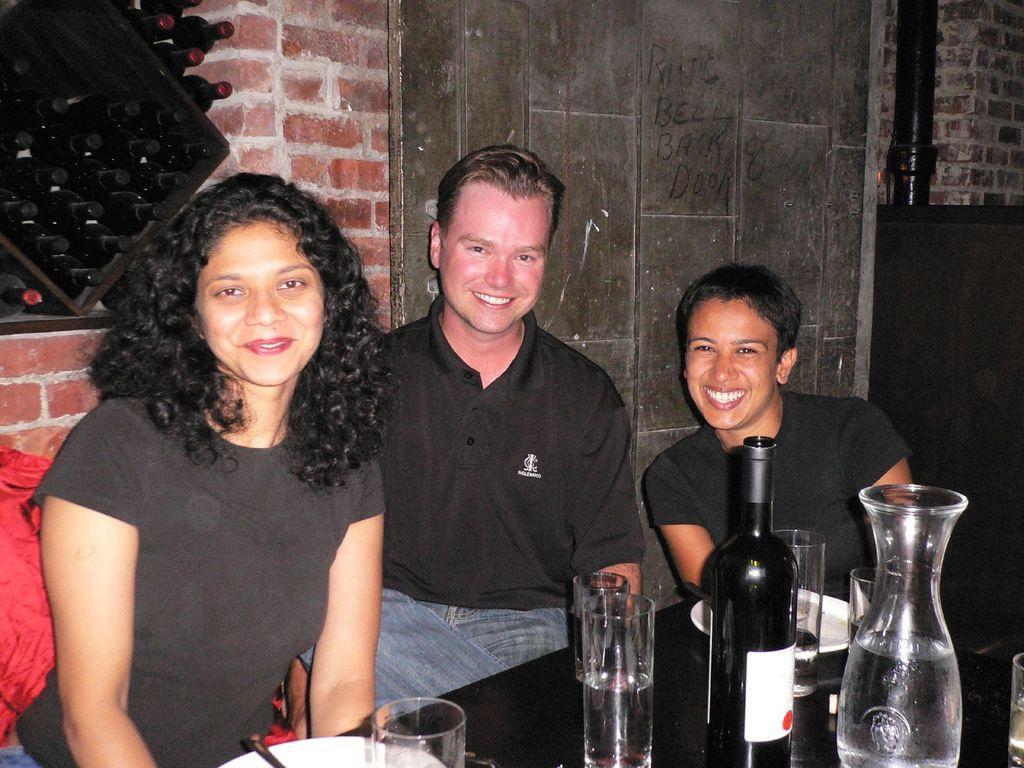In one or two sentences, can you explain what this image depicts? In this image we can see a man and two women sitting and smiling in front of the dining table and on the table we can see the plates, spoons, glasses, jar and also a bottle. In the background we can see the door, wall and also some bottles. 